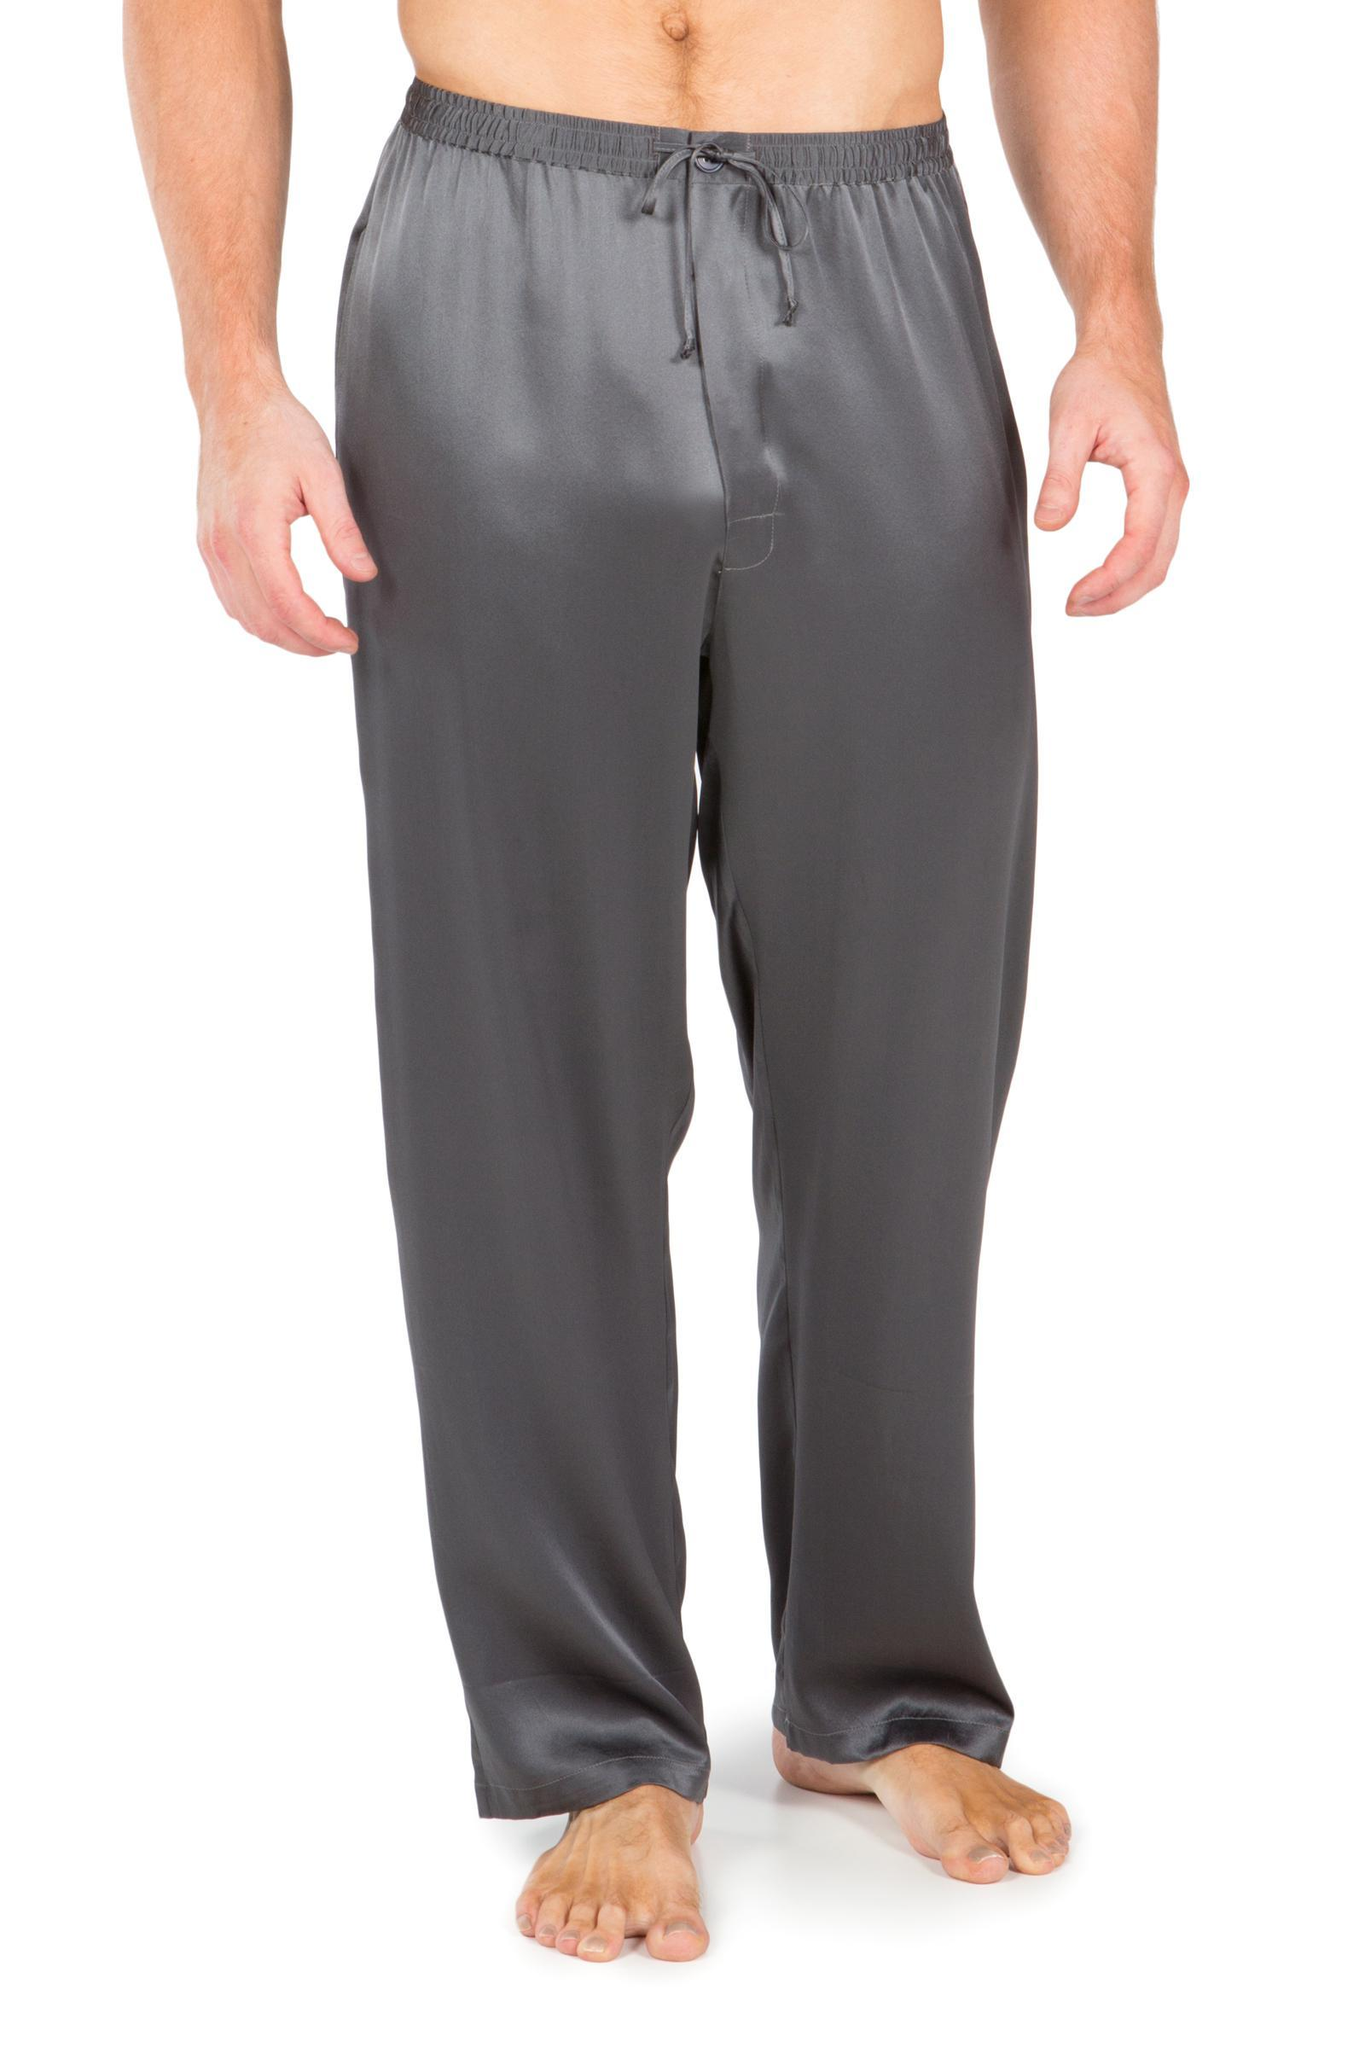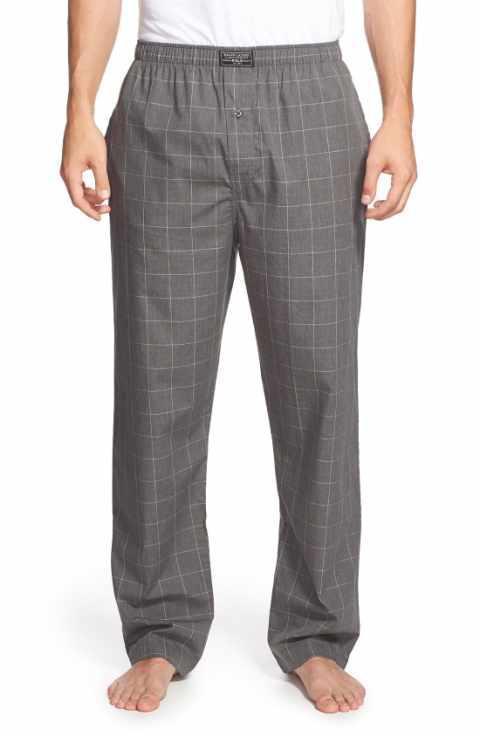The first image is the image on the left, the second image is the image on the right. Given the left and right images, does the statement "One of two models shown is wearing shoes and the other is barefoot." hold true? Answer yes or no. No. 